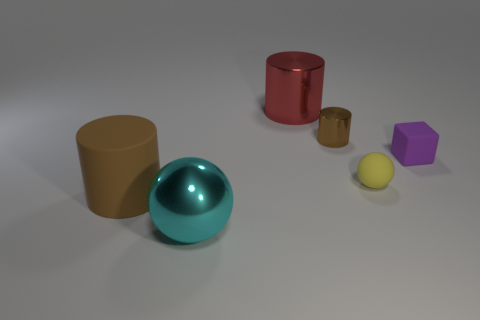Add 3 tiny purple rubber blocks. How many objects exist? 9 Subtract all cubes. How many objects are left? 5 Add 2 large objects. How many large objects are left? 5 Add 3 big balls. How many big balls exist? 4 Subtract 0 blue blocks. How many objects are left? 6 Subtract all large brown matte things. Subtract all tiny spheres. How many objects are left? 4 